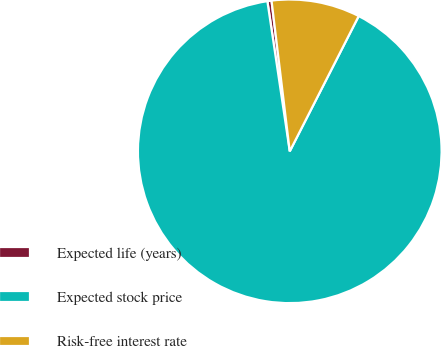<chart> <loc_0><loc_0><loc_500><loc_500><pie_chart><fcel>Expected life (years)<fcel>Expected stock price<fcel>Risk-free interest rate<nl><fcel>0.44%<fcel>90.14%<fcel>9.42%<nl></chart> 